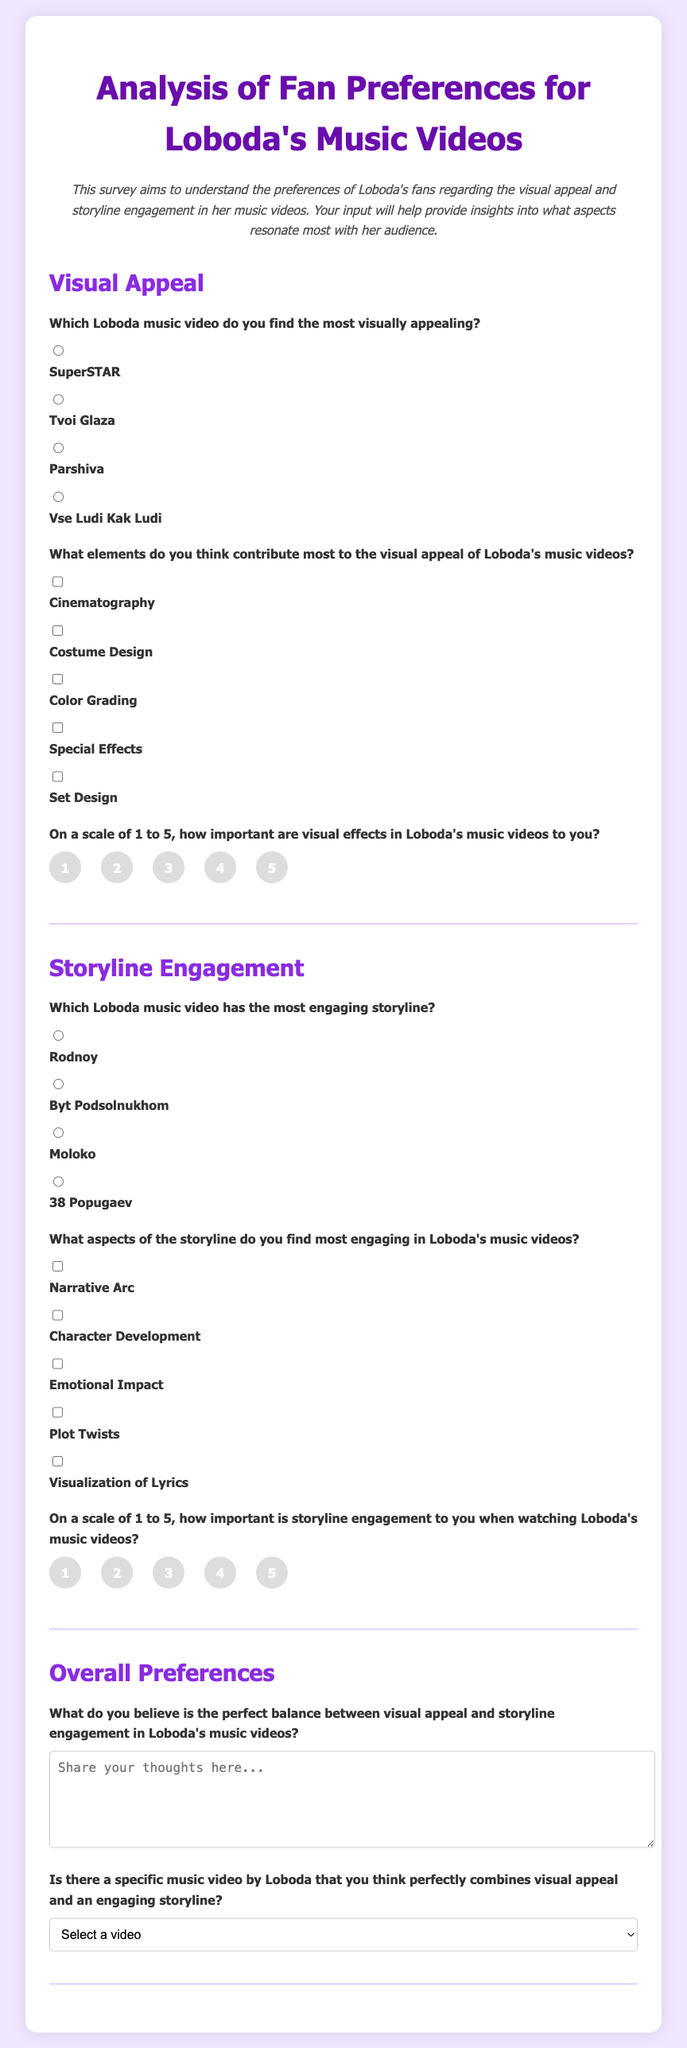Which music video is considered the most visually appealing by fans? Fans indicated their most visually appealing choice among the options provided in the survey.
Answer: SuperSTAR What is one element contributing to the visual appeal of Loboda's music videos? The survey includes checkboxes for fans to select elements they believe enhance visual appeal.
Answer: Cinematography How important are visual effects to fans on a scale of 1 to 5? Fans rated the importance of visual effects in Loboda's music videos from 1 (least important) to 5 (most important).
Answer: 5 Which music video has the most engaging storyline according to fans? The survey asks fans to choose the music video they find has the most engaging storyline.
Answer: Rodnoy What aspect of the storyline do fans find most engaging? Fans selected engaging aspects from the options given in the survey, indicating their preferences.
Answer: Character Development What is the ideal balance between visual appeal and storyline engagement according to fans? Fans provided their opinions in a text area, expressing their thoughts on the balance between visual and storyline elements.
Answer: Perfect harmony Which specific music video is thought to combine visual appeal and an engaging storyline? The dropdown menu offers options for fans to select a music video that represents a combination of both elements.
Answer: Moloko 